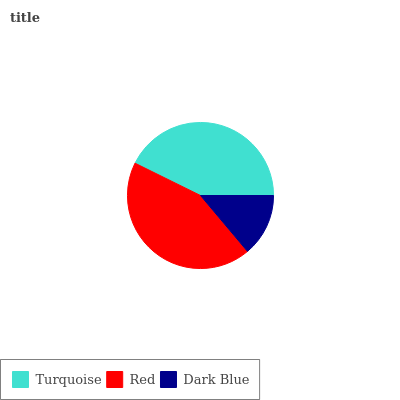Is Dark Blue the minimum?
Answer yes or no. Yes. Is Red the maximum?
Answer yes or no. Yes. Is Red the minimum?
Answer yes or no. No. Is Dark Blue the maximum?
Answer yes or no. No. Is Red greater than Dark Blue?
Answer yes or no. Yes. Is Dark Blue less than Red?
Answer yes or no. Yes. Is Dark Blue greater than Red?
Answer yes or no. No. Is Red less than Dark Blue?
Answer yes or no. No. Is Turquoise the high median?
Answer yes or no. Yes. Is Turquoise the low median?
Answer yes or no. Yes. Is Red the high median?
Answer yes or no. No. Is Dark Blue the low median?
Answer yes or no. No. 